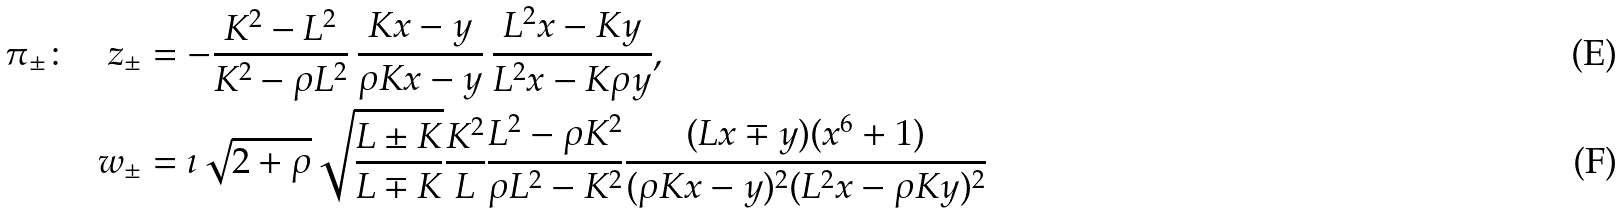Convert formula to latex. <formula><loc_0><loc_0><loc_500><loc_500>\pi _ { \pm } \colon \quad z _ { \pm } & = - \frac { K ^ { 2 } - L ^ { 2 } } { K ^ { 2 } - \rho L ^ { 2 } } \, \frac { K x - y } { \rho K x - y } \, \frac { L ^ { 2 } x - K y } { L ^ { 2 } x - K \rho y } , \\ w _ { \pm } & = \imath \sqrt { 2 + \rho } \sqrt { \frac { L \pm K } { L \mp K } } \frac { K ^ { 2 } } { L } \frac { L ^ { 2 } - \rho K ^ { 2 } } { \rho L ^ { 2 } - K ^ { 2 } } \frac { ( L x \mp y ) ( x ^ { 6 } + 1 ) } { ( \rho K x - y ) ^ { 2 } ( L ^ { 2 } x - \rho K y ) ^ { 2 } }</formula> 